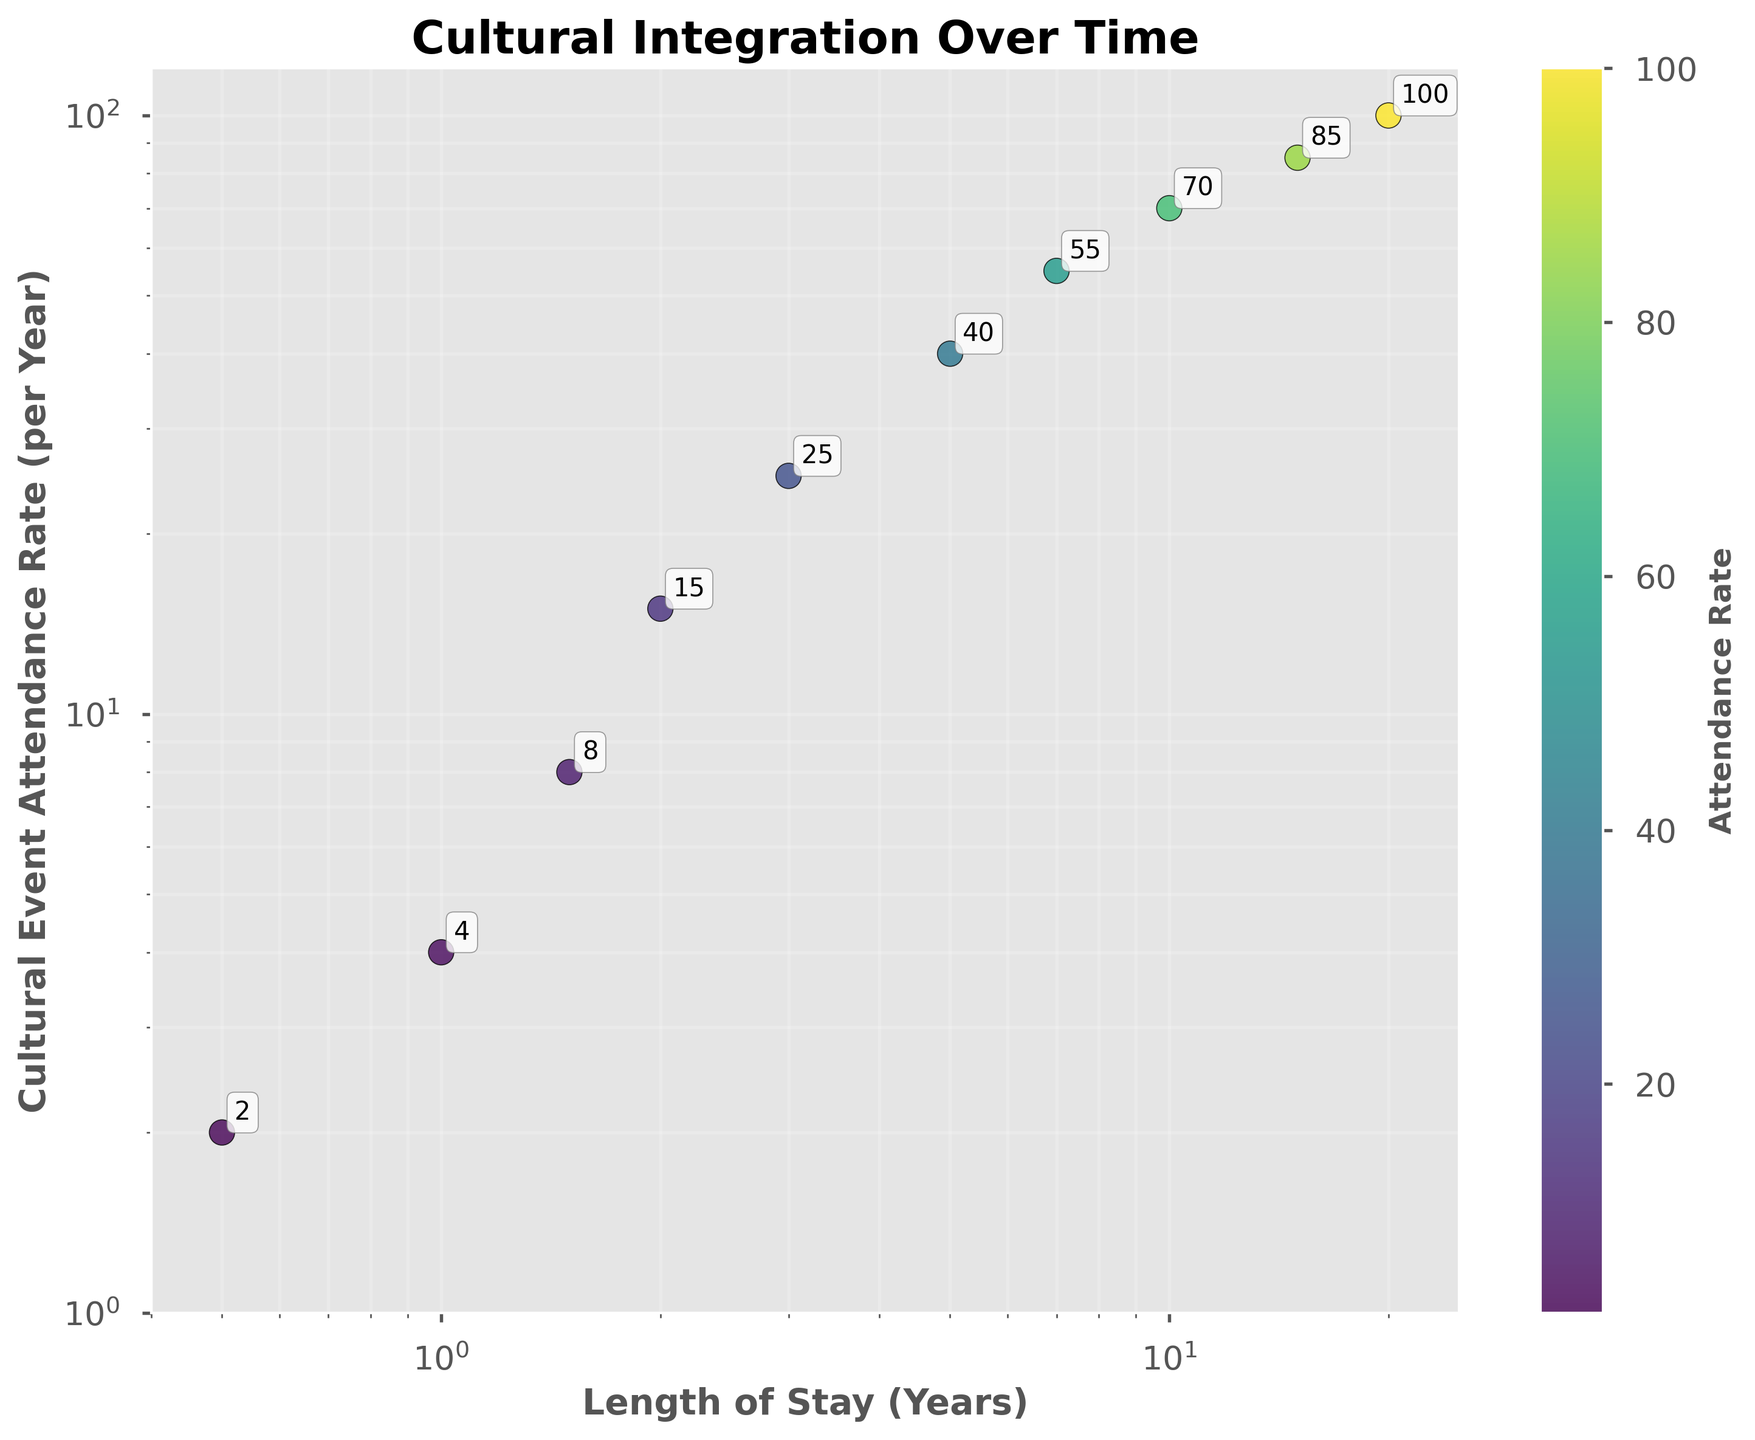How many data points are represented in the scatter plot? By visually inspecting the scatter plot, we can count the number of distinct points plotted on the graph.
Answer: 10 What is the title of the scatter plot? The title is usually displayed prominently at the top of the plot.
Answer: Cultural Integration Over Time What are the axis labels and their units? Axis labels describe what each axis represents and their units of measurement. The x-axis is labeled "Length of Stay (Years)," and the y-axis is labeled "Cultural Event Attendance Rate (per Year)."
Answer: Length of Stay (Years), Cultural Event Attendance Rate (per Year) What is the relationship between Length of Stay and Rate of Cultural Event Attendance? By observing the overall pattern of the scatter plot, we can deduce the trend. Here, as the Length of Stay in years increases, the Rate of Cultural Event Attendance per year also increases, indicating a positive correlation.
Answer: Positive correlation Which data point has the highest Rate of Cultural Event Attendance, and what is its Length of Stay? The highest point on the y-axis represents the highest Rate of Cultural Event Attendance. We can identify its corresponding x-axis value.
Answer: Length of Stay: 20 years, Attendance Rate: 100 Is the relationship between Length of Stay and Attendance Rate exponential or linear, considering the log scales? Considering the log-scaled axes, if the relationship appears linear on a log-log plot, the actual relationship is exponential. The data points form a roughly linear trend on the log-log plot, indicating an exponential relationship.
Answer: Exponential How does the Rate of Cultural Event Attendance change from 0.5 years to 5 years of Length of Stay? Observe the y-values corresponding to x=0.5 and x=5 years. The Attendance Rate increases from 2 to 40 per year.
Answer: Increases from 2 to 40 What is the average Rate of Cultural Event Attendance for Lengths of Stay of 2, 5, and 10 years? Identify the y-values for each x-value (2, 5, and 10 years), then calculate the average: (15 + 40 + 70) / 3 = 125 / 3 ≈ 41.67.
Answer: ≈ 41.67 Which Length of Stay shows an Attendance Rate approximately equal to 55 events per year? Find the data point where the y-value is approximately 55. This occurs at a Length of Stay of 7 years.
Answer: 7 years By what factor does the Rate of Cultural Event Attendance increase from 1 year to 15 years? Identify the y-values for 1 year and 15 years (4 and 85, respectively). The factor of increase is 85 / 4 = 21.25.
Answer: 21.25 